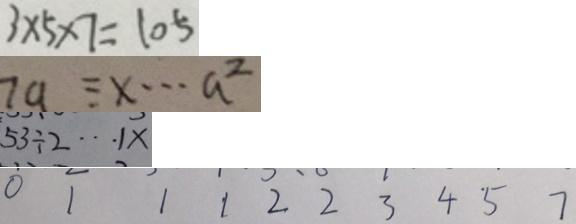Convert formula to latex. <formula><loc_0><loc_0><loc_500><loc_500>3 \times 5 \times 7 = 1 0 5 
 7 a \equiv x \cdots a ^ { 2 } 
 5 3 \div 2 \cdots 1 x 
 0 1 1 1 2 2 3 4 5 7</formula> 